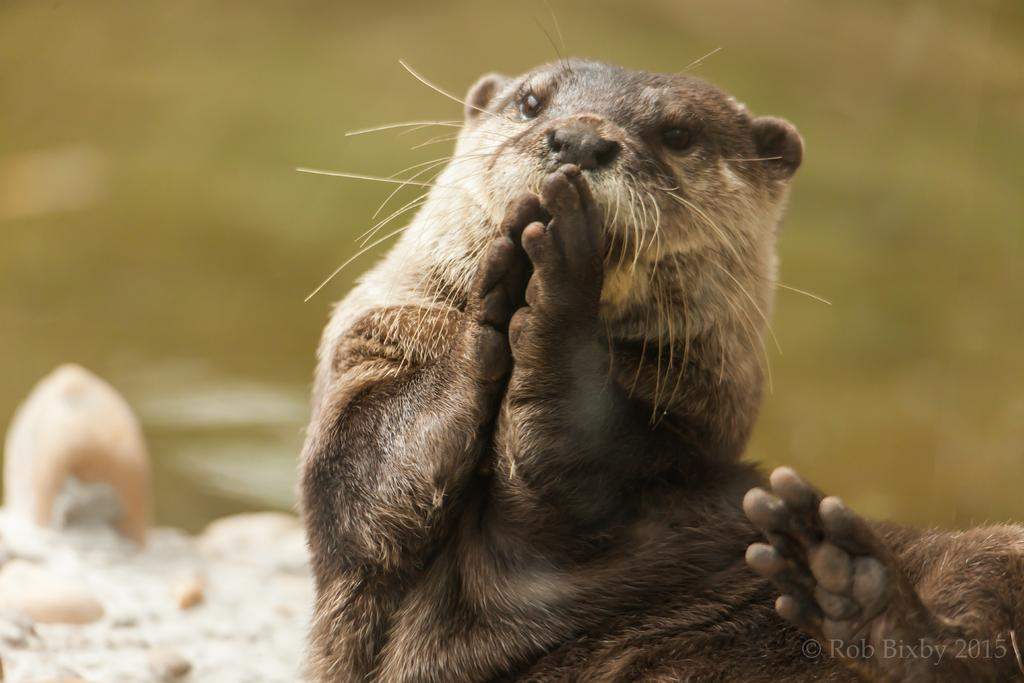What is the main subject of the image? There is a Punxsutawney Phil in the image. Can you describe the background of the image? The background of the image is blurry. Is there any text present in the image? Yes, there is some text at the bottom right corner of the image. How many lizards can be seen crawling on the Punxsutawney Phil in the image? There are no lizards present in the image; it features Punxsutawney Phil alone. What type of cheese is being used to create a quiet environment in the image? There is no cheese present in the image, and the environment is not described as quiet. 